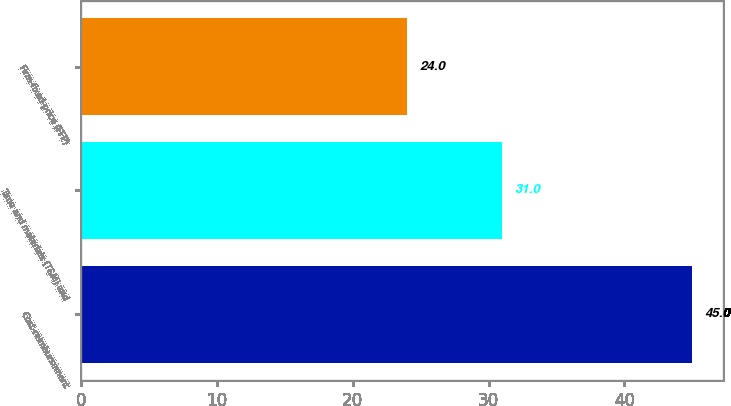<chart> <loc_0><loc_0><loc_500><loc_500><bar_chart><fcel>Cost-reimbursement<fcel>Time and materials (T&M) and<fcel>Firm-fixed-price (FFP)<nl><fcel>45<fcel>31<fcel>24<nl></chart> 